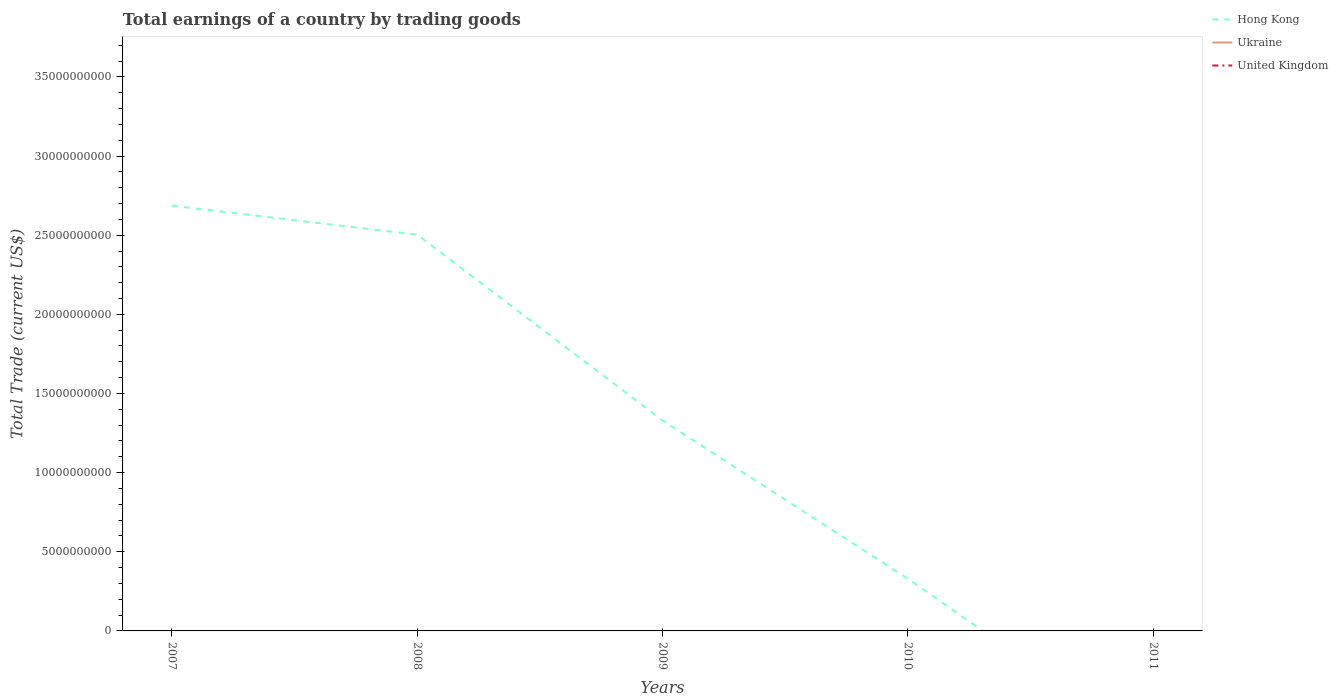How many different coloured lines are there?
Your answer should be compact. 1. Is the number of lines equal to the number of legend labels?
Offer a very short reply. No. What is the total total earnings in Hong Kong in the graph?
Make the answer very short. 2.17e+1. Is the total earnings in Ukraine strictly greater than the total earnings in Hong Kong over the years?
Make the answer very short. Yes. How many lines are there?
Your answer should be compact. 1. Where does the legend appear in the graph?
Ensure brevity in your answer.  Top right. How are the legend labels stacked?
Keep it short and to the point. Vertical. What is the title of the graph?
Your answer should be compact. Total earnings of a country by trading goods. Does "Georgia" appear as one of the legend labels in the graph?
Give a very brief answer. No. What is the label or title of the Y-axis?
Give a very brief answer. Total Trade (current US$). What is the Total Trade (current US$) in Hong Kong in 2007?
Offer a very short reply. 2.69e+1. What is the Total Trade (current US$) of Ukraine in 2007?
Keep it short and to the point. 0. What is the Total Trade (current US$) of United Kingdom in 2007?
Your response must be concise. 0. What is the Total Trade (current US$) of Hong Kong in 2008?
Your answer should be very brief. 2.50e+1. What is the Total Trade (current US$) in United Kingdom in 2008?
Your answer should be compact. 0. What is the Total Trade (current US$) in Hong Kong in 2009?
Make the answer very short. 1.33e+1. What is the Total Trade (current US$) in Ukraine in 2009?
Keep it short and to the point. 0. What is the Total Trade (current US$) of Hong Kong in 2010?
Make the answer very short. 3.29e+09. What is the Total Trade (current US$) in Ukraine in 2010?
Provide a succinct answer. 0. What is the Total Trade (current US$) in United Kingdom in 2010?
Your response must be concise. 0. What is the Total Trade (current US$) of Hong Kong in 2011?
Your answer should be compact. 0. Across all years, what is the maximum Total Trade (current US$) in Hong Kong?
Your answer should be very brief. 2.69e+1. Across all years, what is the minimum Total Trade (current US$) in Hong Kong?
Your response must be concise. 0. What is the total Total Trade (current US$) of Hong Kong in the graph?
Ensure brevity in your answer.  6.85e+1. What is the total Total Trade (current US$) of United Kingdom in the graph?
Keep it short and to the point. 0. What is the difference between the Total Trade (current US$) of Hong Kong in 2007 and that in 2008?
Keep it short and to the point. 1.83e+09. What is the difference between the Total Trade (current US$) in Hong Kong in 2007 and that in 2009?
Provide a succinct answer. 1.36e+1. What is the difference between the Total Trade (current US$) of Hong Kong in 2007 and that in 2010?
Offer a very short reply. 2.36e+1. What is the difference between the Total Trade (current US$) of Hong Kong in 2008 and that in 2009?
Offer a very short reply. 1.17e+1. What is the difference between the Total Trade (current US$) of Hong Kong in 2008 and that in 2010?
Ensure brevity in your answer.  2.17e+1. What is the difference between the Total Trade (current US$) of Hong Kong in 2009 and that in 2010?
Make the answer very short. 1.00e+1. What is the average Total Trade (current US$) of Hong Kong per year?
Offer a terse response. 1.37e+1. What is the average Total Trade (current US$) in Ukraine per year?
Your response must be concise. 0. What is the ratio of the Total Trade (current US$) in Hong Kong in 2007 to that in 2008?
Keep it short and to the point. 1.07. What is the ratio of the Total Trade (current US$) of Hong Kong in 2007 to that in 2009?
Give a very brief answer. 2.02. What is the ratio of the Total Trade (current US$) in Hong Kong in 2007 to that in 2010?
Provide a succinct answer. 8.16. What is the ratio of the Total Trade (current US$) in Hong Kong in 2008 to that in 2009?
Provide a short and direct response. 1.88. What is the ratio of the Total Trade (current US$) in Hong Kong in 2008 to that in 2010?
Give a very brief answer. 7.6. What is the ratio of the Total Trade (current US$) of Hong Kong in 2009 to that in 2010?
Give a very brief answer. 4.04. What is the difference between the highest and the second highest Total Trade (current US$) in Hong Kong?
Give a very brief answer. 1.83e+09. What is the difference between the highest and the lowest Total Trade (current US$) in Hong Kong?
Provide a succinct answer. 2.69e+1. 